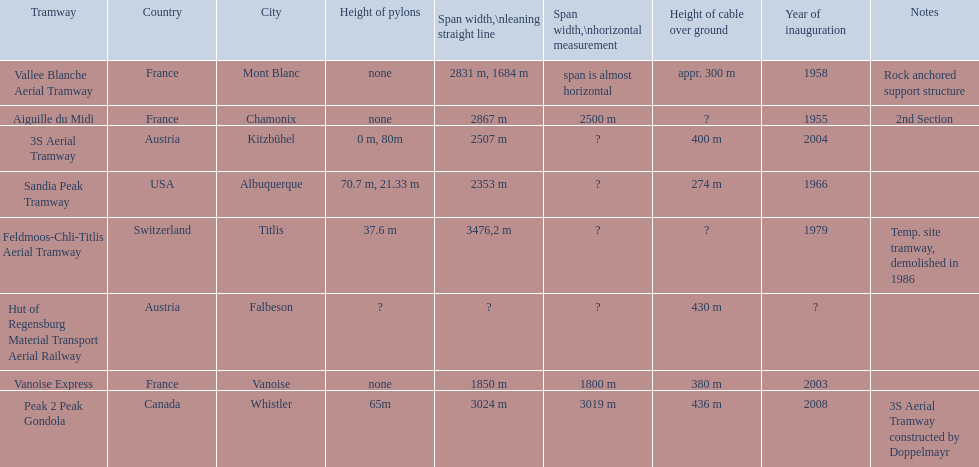What are all of the tramways? Peak 2 Peak Gondola, Hut of Regensburg Material Transport Aerial Railway, Vanoise Express, Aiguille du Midi, Vallee Blanche Aerial Tramway, 3S Aerial Tramway, Sandia Peak Tramway, Feldmoos-Chli-Titlis Aerial Tramway. When were they inaugurated? 2008, ?, 2003, 1955, 1958, 2004, 1966, 1979. Now, between 3s aerial tramway and aiguille du midi, which was inaugurated first? Aiguille du Midi. 